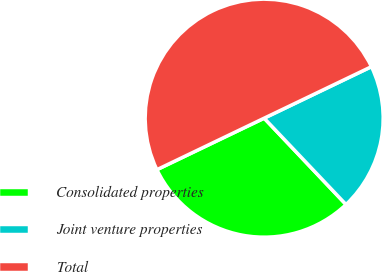<chart> <loc_0><loc_0><loc_500><loc_500><pie_chart><fcel>Consolidated properties<fcel>Joint venture properties<fcel>Total<nl><fcel>29.95%<fcel>20.05%<fcel>50.0%<nl></chart> 